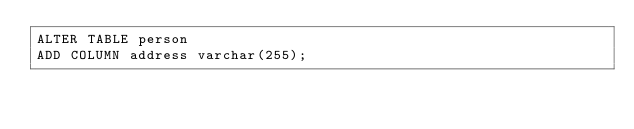<code> <loc_0><loc_0><loc_500><loc_500><_SQL_>ALTER TABLE person
ADD COLUMN address varchar(255);
</code> 